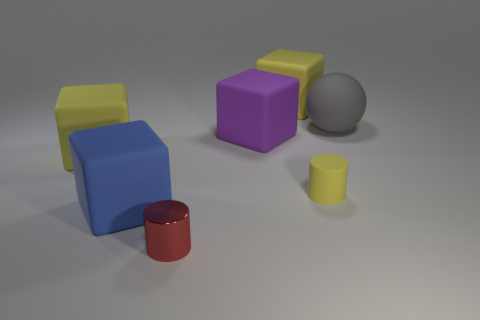What shapes can you see and what colors are they? In the image, there is a variety of shapes including two cylinders, three cubes, and two rectangular blocks. The cylinders are red and yellow, cubes are yellow, purple, and blue, and the rectangular blocks are yellow and blue. Additionally, there are two small gray cylindrical shapes. 